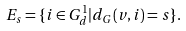<formula> <loc_0><loc_0><loc_500><loc_500>E _ { s } = \{ i \in G ^ { 1 } _ { d } | d _ { G } ( v , i ) = s \} .</formula> 